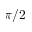<formula> <loc_0><loc_0><loc_500><loc_500>\pi / 2</formula> 